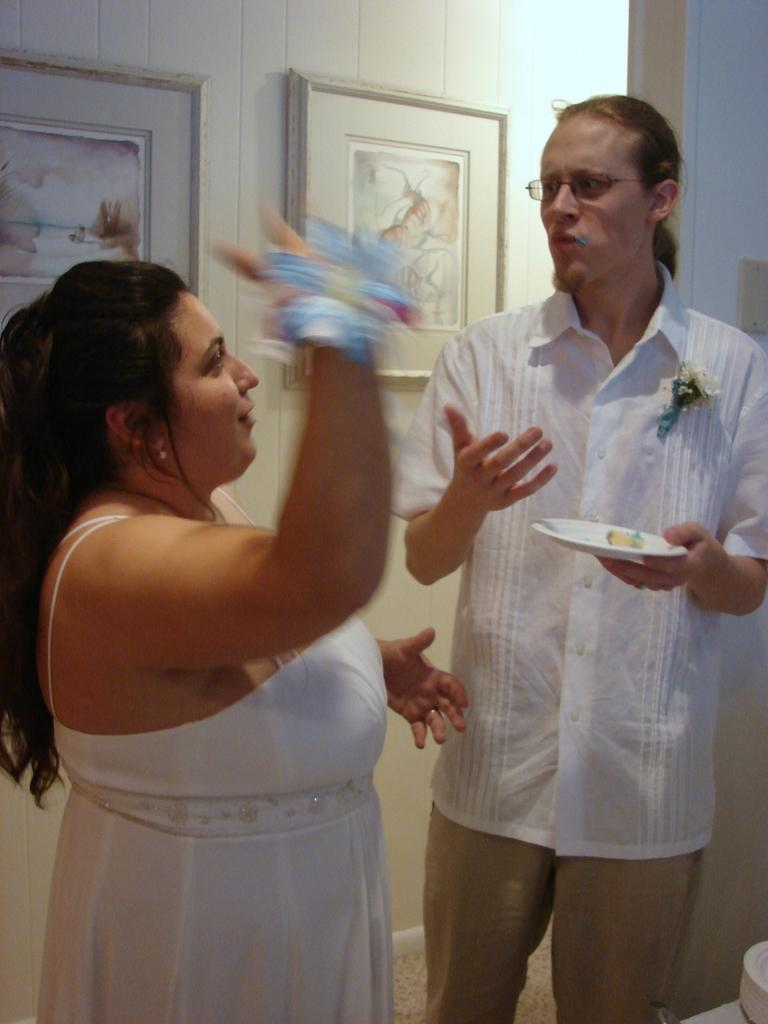How many people are present in the image? There are two people in the image, a man and a woman. What are the man and the woman doing in the image? Both the man and the woman are standing on the floor. Who is holding a serving plate in the image? One of them, either the man or the woman, is holding a serving plate in their hands. What can be seen in the background of the image? There are wall hangings visible in the background of the image. How many toads are sitting on the serving plate in the image? There are no toads present in the image, and the serving plate is not mentioned to be holding any toads. What type of stamp can be seen on the wall hanging in the image? There is no stamp visible on the wall hangings in the image. 